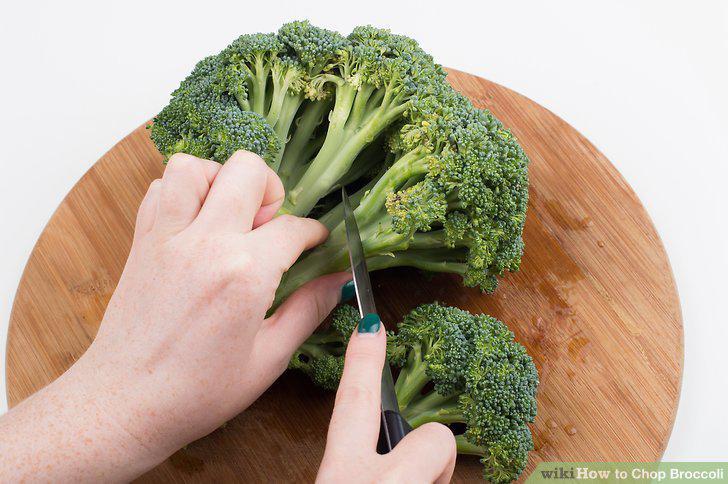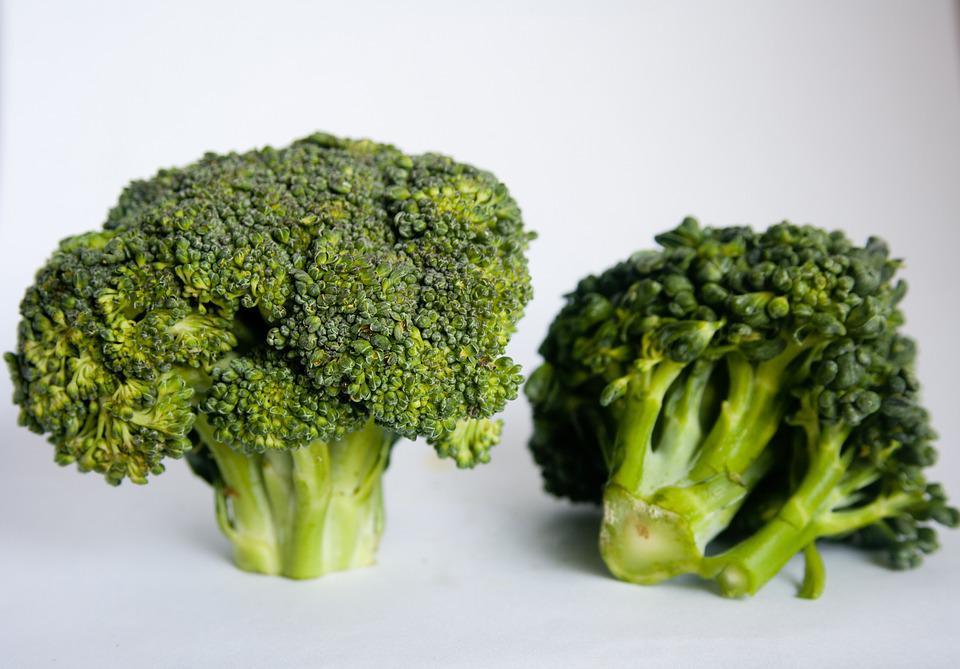The first image is the image on the left, the second image is the image on the right. Evaluate the accuracy of this statement regarding the images: "All of the images only feature broccoli pieces and nothing else.". Is it true? Answer yes or no. No. The first image is the image on the left, the second image is the image on the right. Evaluate the accuracy of this statement regarding the images: "One image shows broccoli florets that are on some type of roundish item.". Is it true? Answer yes or no. Yes. 